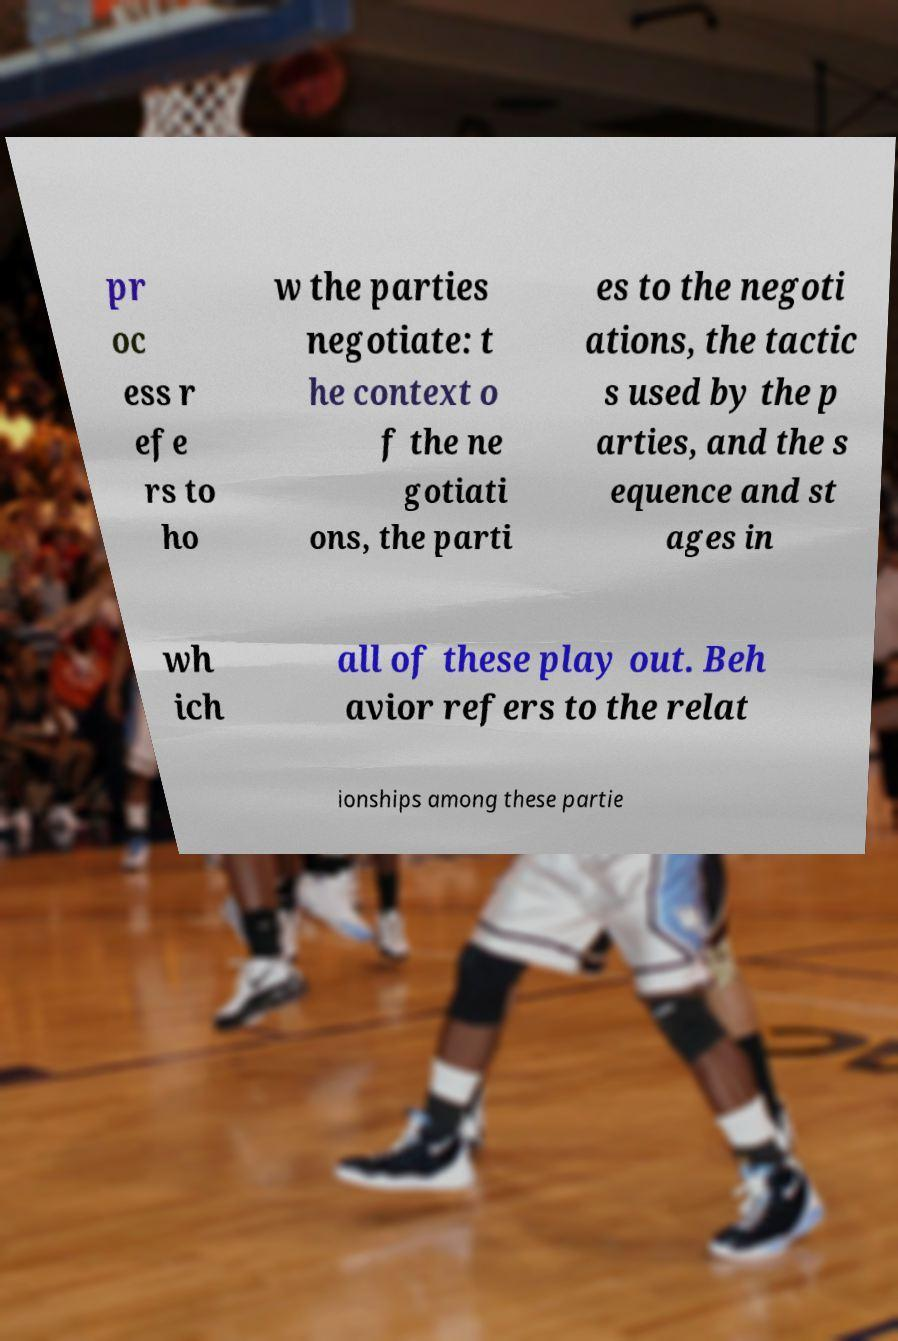I need the written content from this picture converted into text. Can you do that? pr oc ess r efe rs to ho w the parties negotiate: t he context o f the ne gotiati ons, the parti es to the negoti ations, the tactic s used by the p arties, and the s equence and st ages in wh ich all of these play out. Beh avior refers to the relat ionships among these partie 